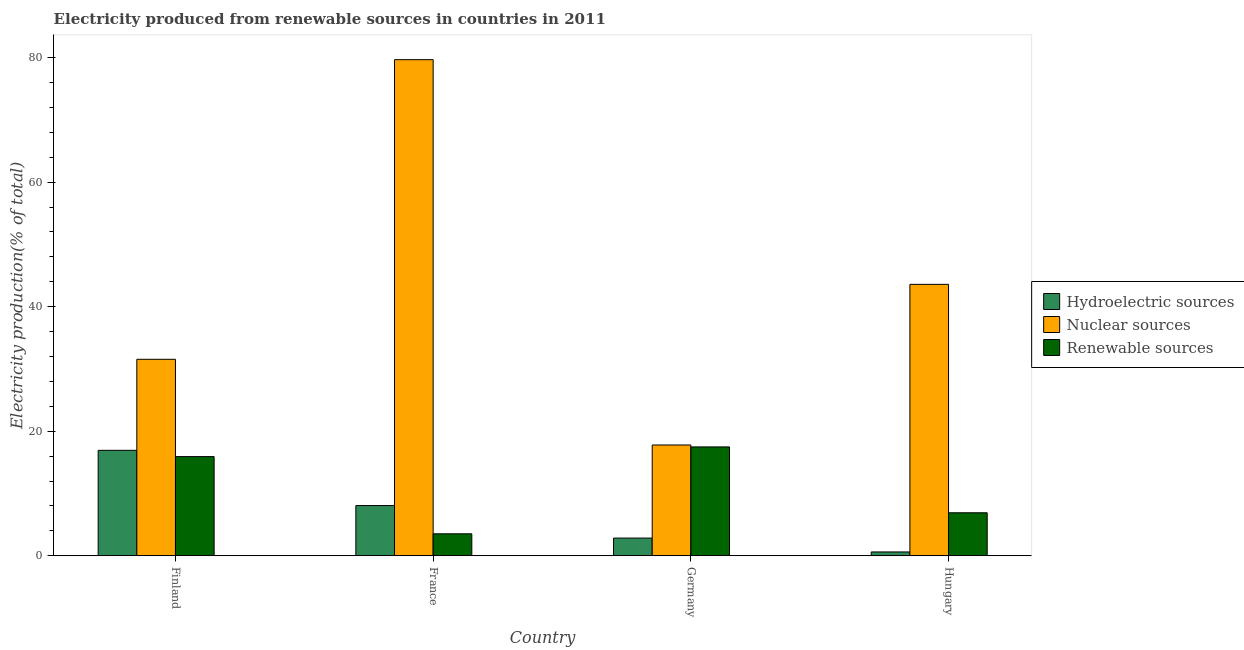How many bars are there on the 4th tick from the left?
Keep it short and to the point. 3. What is the label of the 4th group of bars from the left?
Make the answer very short. Hungary. What is the percentage of electricity produced by renewable sources in Hungary?
Ensure brevity in your answer.  6.91. Across all countries, what is the maximum percentage of electricity produced by renewable sources?
Keep it short and to the point. 17.48. Across all countries, what is the minimum percentage of electricity produced by hydroelectric sources?
Offer a very short reply. 0.62. In which country was the percentage of electricity produced by hydroelectric sources minimum?
Offer a very short reply. Hungary. What is the total percentage of electricity produced by nuclear sources in the graph?
Offer a terse response. 172.61. What is the difference between the percentage of electricity produced by renewable sources in Finland and that in Germany?
Your response must be concise. -1.56. What is the difference between the percentage of electricity produced by hydroelectric sources in Hungary and the percentage of electricity produced by nuclear sources in Germany?
Make the answer very short. -17.18. What is the average percentage of electricity produced by nuclear sources per country?
Your response must be concise. 43.15. What is the difference between the percentage of electricity produced by renewable sources and percentage of electricity produced by hydroelectric sources in France?
Your response must be concise. -4.54. In how many countries, is the percentage of electricity produced by renewable sources greater than 16 %?
Provide a short and direct response. 1. What is the ratio of the percentage of electricity produced by hydroelectric sources in Finland to that in Germany?
Offer a terse response. 5.95. Is the percentage of electricity produced by hydroelectric sources in France less than that in Hungary?
Provide a succinct answer. No. What is the difference between the highest and the second highest percentage of electricity produced by renewable sources?
Make the answer very short. 1.56. What is the difference between the highest and the lowest percentage of electricity produced by renewable sources?
Ensure brevity in your answer.  13.95. In how many countries, is the percentage of electricity produced by hydroelectric sources greater than the average percentage of electricity produced by hydroelectric sources taken over all countries?
Your answer should be very brief. 2. What does the 1st bar from the left in France represents?
Keep it short and to the point. Hydroelectric sources. What does the 1st bar from the right in Germany represents?
Keep it short and to the point. Renewable sources. Is it the case that in every country, the sum of the percentage of electricity produced by hydroelectric sources and percentage of electricity produced by nuclear sources is greater than the percentage of electricity produced by renewable sources?
Make the answer very short. Yes. How many bars are there?
Provide a succinct answer. 12. What is the difference between two consecutive major ticks on the Y-axis?
Keep it short and to the point. 20. Does the graph contain any zero values?
Your answer should be very brief. No. How many legend labels are there?
Your response must be concise. 3. How are the legend labels stacked?
Keep it short and to the point. Vertical. What is the title of the graph?
Your response must be concise. Electricity produced from renewable sources in countries in 2011. What is the Electricity production(% of total) in Hydroelectric sources in Finland?
Make the answer very short. 16.94. What is the Electricity production(% of total) of Nuclear sources in Finland?
Keep it short and to the point. 31.56. What is the Electricity production(% of total) of Renewable sources in Finland?
Your response must be concise. 15.93. What is the Electricity production(% of total) in Hydroelectric sources in France?
Make the answer very short. 8.07. What is the Electricity production(% of total) in Nuclear sources in France?
Provide a succinct answer. 79.67. What is the Electricity production(% of total) of Renewable sources in France?
Your response must be concise. 3.53. What is the Electricity production(% of total) of Hydroelectric sources in Germany?
Provide a succinct answer. 2.85. What is the Electricity production(% of total) in Nuclear sources in Germany?
Ensure brevity in your answer.  17.79. What is the Electricity production(% of total) in Renewable sources in Germany?
Provide a short and direct response. 17.48. What is the Electricity production(% of total) of Hydroelectric sources in Hungary?
Keep it short and to the point. 0.62. What is the Electricity production(% of total) of Nuclear sources in Hungary?
Ensure brevity in your answer.  43.59. What is the Electricity production(% of total) of Renewable sources in Hungary?
Offer a very short reply. 6.91. Across all countries, what is the maximum Electricity production(% of total) of Hydroelectric sources?
Your answer should be very brief. 16.94. Across all countries, what is the maximum Electricity production(% of total) in Nuclear sources?
Offer a very short reply. 79.67. Across all countries, what is the maximum Electricity production(% of total) in Renewable sources?
Your answer should be compact. 17.48. Across all countries, what is the minimum Electricity production(% of total) in Hydroelectric sources?
Provide a succinct answer. 0.62. Across all countries, what is the minimum Electricity production(% of total) of Nuclear sources?
Your answer should be very brief. 17.79. Across all countries, what is the minimum Electricity production(% of total) in Renewable sources?
Offer a very short reply. 3.53. What is the total Electricity production(% of total) of Hydroelectric sources in the graph?
Your response must be concise. 28.46. What is the total Electricity production(% of total) in Nuclear sources in the graph?
Your answer should be compact. 172.61. What is the total Electricity production(% of total) of Renewable sources in the graph?
Provide a succinct answer. 43.85. What is the difference between the Electricity production(% of total) in Hydroelectric sources in Finland and that in France?
Give a very brief answer. 8.87. What is the difference between the Electricity production(% of total) in Nuclear sources in Finland and that in France?
Keep it short and to the point. -48.11. What is the difference between the Electricity production(% of total) of Renewable sources in Finland and that in France?
Your answer should be very brief. 12.4. What is the difference between the Electricity production(% of total) in Hydroelectric sources in Finland and that in Germany?
Offer a terse response. 14.09. What is the difference between the Electricity production(% of total) of Nuclear sources in Finland and that in Germany?
Keep it short and to the point. 13.76. What is the difference between the Electricity production(% of total) of Renewable sources in Finland and that in Germany?
Ensure brevity in your answer.  -1.56. What is the difference between the Electricity production(% of total) in Hydroelectric sources in Finland and that in Hungary?
Offer a terse response. 16.32. What is the difference between the Electricity production(% of total) in Nuclear sources in Finland and that in Hungary?
Offer a terse response. -12.03. What is the difference between the Electricity production(% of total) of Renewable sources in Finland and that in Hungary?
Your answer should be very brief. 9.02. What is the difference between the Electricity production(% of total) in Hydroelectric sources in France and that in Germany?
Offer a terse response. 5.22. What is the difference between the Electricity production(% of total) in Nuclear sources in France and that in Germany?
Keep it short and to the point. 61.88. What is the difference between the Electricity production(% of total) of Renewable sources in France and that in Germany?
Provide a short and direct response. -13.95. What is the difference between the Electricity production(% of total) in Hydroelectric sources in France and that in Hungary?
Your answer should be compact. 7.45. What is the difference between the Electricity production(% of total) in Nuclear sources in France and that in Hungary?
Make the answer very short. 36.08. What is the difference between the Electricity production(% of total) of Renewable sources in France and that in Hungary?
Make the answer very short. -3.38. What is the difference between the Electricity production(% of total) of Hydroelectric sources in Germany and that in Hungary?
Your answer should be compact. 2.23. What is the difference between the Electricity production(% of total) of Nuclear sources in Germany and that in Hungary?
Your answer should be compact. -25.8. What is the difference between the Electricity production(% of total) of Renewable sources in Germany and that in Hungary?
Provide a succinct answer. 10.58. What is the difference between the Electricity production(% of total) in Hydroelectric sources in Finland and the Electricity production(% of total) in Nuclear sources in France?
Your response must be concise. -62.73. What is the difference between the Electricity production(% of total) of Hydroelectric sources in Finland and the Electricity production(% of total) of Renewable sources in France?
Offer a terse response. 13.41. What is the difference between the Electricity production(% of total) in Nuclear sources in Finland and the Electricity production(% of total) in Renewable sources in France?
Give a very brief answer. 28.02. What is the difference between the Electricity production(% of total) in Hydroelectric sources in Finland and the Electricity production(% of total) in Nuclear sources in Germany?
Ensure brevity in your answer.  -0.86. What is the difference between the Electricity production(% of total) of Hydroelectric sources in Finland and the Electricity production(% of total) of Renewable sources in Germany?
Make the answer very short. -0.55. What is the difference between the Electricity production(% of total) in Nuclear sources in Finland and the Electricity production(% of total) in Renewable sources in Germany?
Provide a short and direct response. 14.07. What is the difference between the Electricity production(% of total) of Hydroelectric sources in Finland and the Electricity production(% of total) of Nuclear sources in Hungary?
Provide a short and direct response. -26.65. What is the difference between the Electricity production(% of total) in Hydroelectric sources in Finland and the Electricity production(% of total) in Renewable sources in Hungary?
Ensure brevity in your answer.  10.03. What is the difference between the Electricity production(% of total) in Nuclear sources in Finland and the Electricity production(% of total) in Renewable sources in Hungary?
Provide a short and direct response. 24.65. What is the difference between the Electricity production(% of total) of Hydroelectric sources in France and the Electricity production(% of total) of Nuclear sources in Germany?
Your answer should be compact. -9.73. What is the difference between the Electricity production(% of total) in Hydroelectric sources in France and the Electricity production(% of total) in Renewable sources in Germany?
Give a very brief answer. -9.42. What is the difference between the Electricity production(% of total) of Nuclear sources in France and the Electricity production(% of total) of Renewable sources in Germany?
Offer a terse response. 62.19. What is the difference between the Electricity production(% of total) of Hydroelectric sources in France and the Electricity production(% of total) of Nuclear sources in Hungary?
Offer a terse response. -35.52. What is the difference between the Electricity production(% of total) of Hydroelectric sources in France and the Electricity production(% of total) of Renewable sources in Hungary?
Give a very brief answer. 1.16. What is the difference between the Electricity production(% of total) in Nuclear sources in France and the Electricity production(% of total) in Renewable sources in Hungary?
Your response must be concise. 72.76. What is the difference between the Electricity production(% of total) in Hydroelectric sources in Germany and the Electricity production(% of total) in Nuclear sources in Hungary?
Give a very brief answer. -40.74. What is the difference between the Electricity production(% of total) of Hydroelectric sources in Germany and the Electricity production(% of total) of Renewable sources in Hungary?
Your answer should be compact. -4.06. What is the difference between the Electricity production(% of total) in Nuclear sources in Germany and the Electricity production(% of total) in Renewable sources in Hungary?
Provide a succinct answer. 10.88. What is the average Electricity production(% of total) in Hydroelectric sources per country?
Your answer should be very brief. 7.12. What is the average Electricity production(% of total) in Nuclear sources per country?
Provide a succinct answer. 43.15. What is the average Electricity production(% of total) of Renewable sources per country?
Your answer should be very brief. 10.96. What is the difference between the Electricity production(% of total) of Hydroelectric sources and Electricity production(% of total) of Nuclear sources in Finland?
Provide a succinct answer. -14.62. What is the difference between the Electricity production(% of total) in Hydroelectric sources and Electricity production(% of total) in Renewable sources in Finland?
Give a very brief answer. 1.01. What is the difference between the Electricity production(% of total) in Nuclear sources and Electricity production(% of total) in Renewable sources in Finland?
Make the answer very short. 15.63. What is the difference between the Electricity production(% of total) in Hydroelectric sources and Electricity production(% of total) in Nuclear sources in France?
Provide a short and direct response. -71.6. What is the difference between the Electricity production(% of total) in Hydroelectric sources and Electricity production(% of total) in Renewable sources in France?
Your response must be concise. 4.54. What is the difference between the Electricity production(% of total) of Nuclear sources and Electricity production(% of total) of Renewable sources in France?
Ensure brevity in your answer.  76.14. What is the difference between the Electricity production(% of total) of Hydroelectric sources and Electricity production(% of total) of Nuclear sources in Germany?
Keep it short and to the point. -14.95. What is the difference between the Electricity production(% of total) of Hydroelectric sources and Electricity production(% of total) of Renewable sources in Germany?
Provide a short and direct response. -14.64. What is the difference between the Electricity production(% of total) in Nuclear sources and Electricity production(% of total) in Renewable sources in Germany?
Your answer should be compact. 0.31. What is the difference between the Electricity production(% of total) of Hydroelectric sources and Electricity production(% of total) of Nuclear sources in Hungary?
Offer a very short reply. -42.97. What is the difference between the Electricity production(% of total) in Hydroelectric sources and Electricity production(% of total) in Renewable sources in Hungary?
Offer a terse response. -6.29. What is the difference between the Electricity production(% of total) in Nuclear sources and Electricity production(% of total) in Renewable sources in Hungary?
Make the answer very short. 36.68. What is the ratio of the Electricity production(% of total) in Hydroelectric sources in Finland to that in France?
Your answer should be compact. 2.1. What is the ratio of the Electricity production(% of total) in Nuclear sources in Finland to that in France?
Provide a succinct answer. 0.4. What is the ratio of the Electricity production(% of total) of Renewable sources in Finland to that in France?
Your response must be concise. 4.51. What is the ratio of the Electricity production(% of total) of Hydroelectric sources in Finland to that in Germany?
Offer a terse response. 5.95. What is the ratio of the Electricity production(% of total) in Nuclear sources in Finland to that in Germany?
Provide a succinct answer. 1.77. What is the ratio of the Electricity production(% of total) in Renewable sources in Finland to that in Germany?
Your answer should be compact. 0.91. What is the ratio of the Electricity production(% of total) of Hydroelectric sources in Finland to that in Hungary?
Make the answer very short. 27.45. What is the ratio of the Electricity production(% of total) of Nuclear sources in Finland to that in Hungary?
Keep it short and to the point. 0.72. What is the ratio of the Electricity production(% of total) of Renewable sources in Finland to that in Hungary?
Your answer should be compact. 2.31. What is the ratio of the Electricity production(% of total) in Hydroelectric sources in France to that in Germany?
Make the answer very short. 2.84. What is the ratio of the Electricity production(% of total) of Nuclear sources in France to that in Germany?
Give a very brief answer. 4.48. What is the ratio of the Electricity production(% of total) in Renewable sources in France to that in Germany?
Ensure brevity in your answer.  0.2. What is the ratio of the Electricity production(% of total) in Hydroelectric sources in France to that in Hungary?
Offer a terse response. 13.07. What is the ratio of the Electricity production(% of total) of Nuclear sources in France to that in Hungary?
Provide a succinct answer. 1.83. What is the ratio of the Electricity production(% of total) in Renewable sources in France to that in Hungary?
Give a very brief answer. 0.51. What is the ratio of the Electricity production(% of total) in Hydroelectric sources in Germany to that in Hungary?
Your answer should be compact. 4.61. What is the ratio of the Electricity production(% of total) in Nuclear sources in Germany to that in Hungary?
Offer a very short reply. 0.41. What is the ratio of the Electricity production(% of total) in Renewable sources in Germany to that in Hungary?
Your answer should be compact. 2.53. What is the difference between the highest and the second highest Electricity production(% of total) of Hydroelectric sources?
Keep it short and to the point. 8.87. What is the difference between the highest and the second highest Electricity production(% of total) of Nuclear sources?
Your response must be concise. 36.08. What is the difference between the highest and the second highest Electricity production(% of total) in Renewable sources?
Offer a terse response. 1.56. What is the difference between the highest and the lowest Electricity production(% of total) in Hydroelectric sources?
Your answer should be very brief. 16.32. What is the difference between the highest and the lowest Electricity production(% of total) of Nuclear sources?
Your answer should be very brief. 61.88. What is the difference between the highest and the lowest Electricity production(% of total) of Renewable sources?
Your answer should be compact. 13.95. 